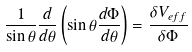<formula> <loc_0><loc_0><loc_500><loc_500>\frac { 1 } { \sin \theta } \frac { d } { d \theta } \left ( \sin \theta \frac { d \Phi } { d \theta } \right ) = \frac { \delta V _ { e f f } } { \delta \Phi }</formula> 